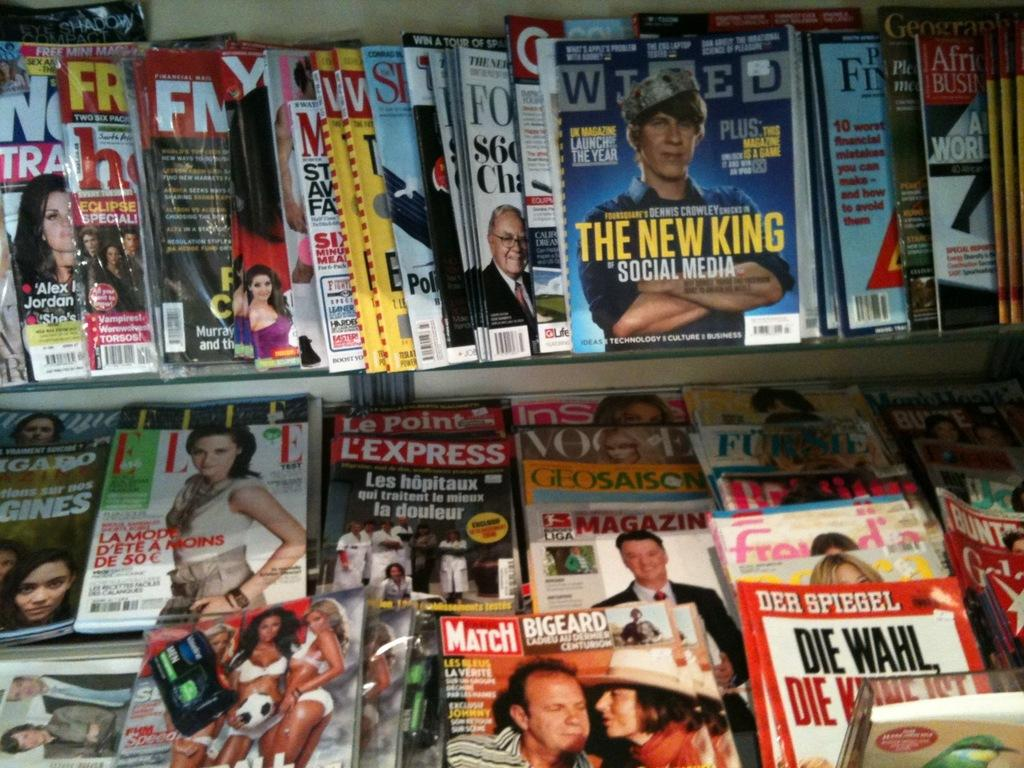<image>
Provide a brief description of the given image. A store shelf covered in magazines, with one listing someone as the new king of social media. 